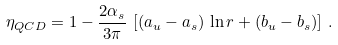Convert formula to latex. <formula><loc_0><loc_0><loc_500><loc_500>\eta _ { Q C D } = 1 - { \frac { 2 \alpha _ { s } } { 3 \pi } } \, \left [ ( a _ { u } - a _ { s } ) \, \ln r + ( b _ { u } - b _ { s } ) \right ] \, .</formula> 